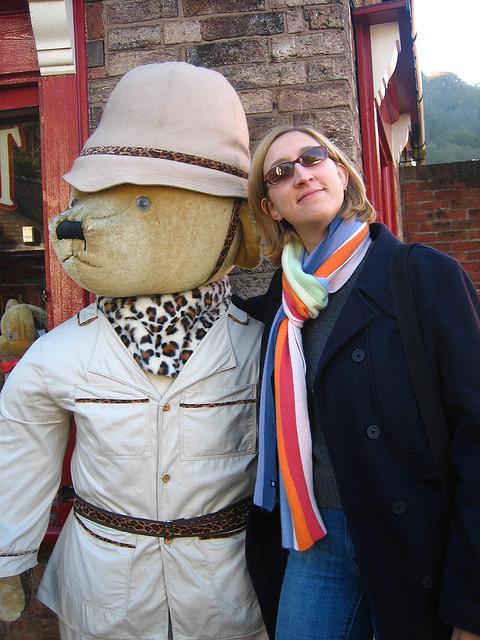What color is her coat?
Answer briefly. Black. Is the bear life size?
Give a very brief answer. Yes. What is in the picture?
Give a very brief answer. Woman and bear. What is the woman on the right wearing?
Quick response, please. Scarf. 